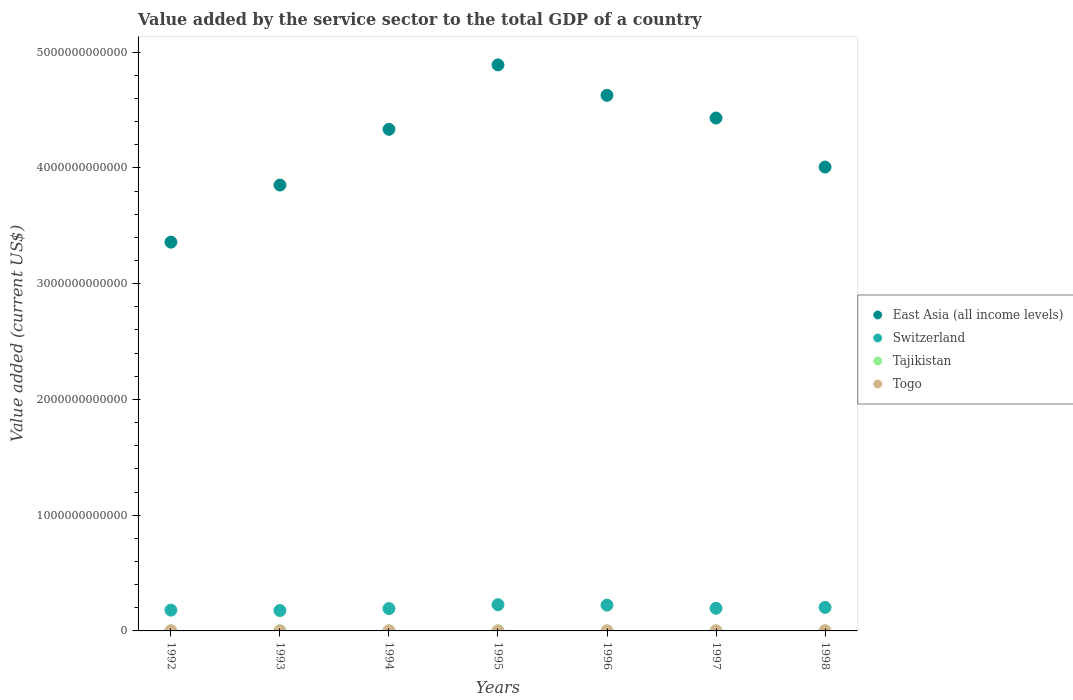What is the value added by the service sector to the total GDP in Switzerland in 1998?
Give a very brief answer. 2.03e+11. Across all years, what is the maximum value added by the service sector to the total GDP in Tajikistan?
Make the answer very short. 5.59e+08. Across all years, what is the minimum value added by the service sector to the total GDP in Togo?
Your answer should be compact. 4.31e+08. In which year was the value added by the service sector to the total GDP in Tajikistan maximum?
Provide a succinct answer. 1998. What is the total value added by the service sector to the total GDP in East Asia (all income levels) in the graph?
Keep it short and to the point. 2.95e+13. What is the difference between the value added by the service sector to the total GDP in Tajikistan in 1992 and that in 1993?
Your answer should be very brief. 9.82e+07. What is the difference between the value added by the service sector to the total GDP in Togo in 1993 and the value added by the service sector to the total GDP in East Asia (all income levels) in 1992?
Ensure brevity in your answer.  -3.36e+12. What is the average value added by the service sector to the total GDP in East Asia (all income levels) per year?
Provide a succinct answer. 4.21e+12. In the year 1994, what is the difference between the value added by the service sector to the total GDP in East Asia (all income levels) and value added by the service sector to the total GDP in Tajikistan?
Your answer should be very brief. 4.33e+12. What is the ratio of the value added by the service sector to the total GDP in East Asia (all income levels) in 1992 to that in 1993?
Make the answer very short. 0.87. What is the difference between the highest and the second highest value added by the service sector to the total GDP in Tajikistan?
Offer a very short reply. 1.32e+07. What is the difference between the highest and the lowest value added by the service sector to the total GDP in East Asia (all income levels)?
Offer a very short reply. 1.53e+12. Does the value added by the service sector to the total GDP in Switzerland monotonically increase over the years?
Give a very brief answer. No. How many dotlines are there?
Ensure brevity in your answer.  4. What is the difference between two consecutive major ticks on the Y-axis?
Provide a short and direct response. 1.00e+12. Does the graph contain any zero values?
Your response must be concise. No. How many legend labels are there?
Your answer should be very brief. 4. What is the title of the graph?
Make the answer very short. Value added by the service sector to the total GDP of a country. Does "Heavily indebted poor countries" appear as one of the legend labels in the graph?
Your response must be concise. No. What is the label or title of the Y-axis?
Ensure brevity in your answer.  Value added (current US$). What is the Value added (current US$) of East Asia (all income levels) in 1992?
Your answer should be compact. 3.36e+12. What is the Value added (current US$) in Switzerland in 1992?
Offer a very short reply. 1.80e+11. What is the Value added (current US$) of Tajikistan in 1992?
Provide a short and direct response. 5.46e+08. What is the Value added (current US$) of Togo in 1992?
Your answer should be very brief. 6.93e+08. What is the Value added (current US$) in East Asia (all income levels) in 1993?
Ensure brevity in your answer.  3.85e+12. What is the Value added (current US$) of Switzerland in 1993?
Ensure brevity in your answer.  1.76e+11. What is the Value added (current US$) of Tajikistan in 1993?
Ensure brevity in your answer.  4.48e+08. What is the Value added (current US$) of Togo in 1993?
Ensure brevity in your answer.  4.34e+08. What is the Value added (current US$) in East Asia (all income levels) in 1994?
Provide a succinct answer. 4.33e+12. What is the Value added (current US$) in Switzerland in 1994?
Offer a terse response. 1.93e+11. What is the Value added (current US$) in Tajikistan in 1994?
Offer a terse response. 3.75e+08. What is the Value added (current US$) in Togo in 1994?
Give a very brief answer. 4.31e+08. What is the Value added (current US$) of East Asia (all income levels) in 1995?
Your answer should be compact. 4.89e+12. What is the Value added (current US$) in Switzerland in 1995?
Offer a terse response. 2.27e+11. What is the Value added (current US$) in Tajikistan in 1995?
Provide a short and direct response. 2.61e+08. What is the Value added (current US$) in Togo in 1995?
Ensure brevity in your answer.  5.24e+08. What is the Value added (current US$) in East Asia (all income levels) in 1996?
Your answer should be compact. 4.63e+12. What is the Value added (current US$) of Switzerland in 1996?
Your answer should be compact. 2.23e+11. What is the Value added (current US$) in Tajikistan in 1996?
Give a very brief answer. 2.84e+08. What is the Value added (current US$) in Togo in 1996?
Ensure brevity in your answer.  5.58e+08. What is the Value added (current US$) in East Asia (all income levels) in 1997?
Offer a terse response. 4.43e+12. What is the Value added (current US$) of Switzerland in 1997?
Provide a short and direct response. 1.96e+11. What is the Value added (current US$) of Tajikistan in 1997?
Give a very brief answer. 2.99e+08. What is the Value added (current US$) in Togo in 1997?
Your response must be concise. 5.65e+08. What is the Value added (current US$) of East Asia (all income levels) in 1998?
Ensure brevity in your answer.  4.01e+12. What is the Value added (current US$) in Switzerland in 1998?
Ensure brevity in your answer.  2.03e+11. What is the Value added (current US$) of Tajikistan in 1998?
Keep it short and to the point. 5.59e+08. What is the Value added (current US$) of Togo in 1998?
Your answer should be very brief. 7.65e+08. Across all years, what is the maximum Value added (current US$) of East Asia (all income levels)?
Provide a short and direct response. 4.89e+12. Across all years, what is the maximum Value added (current US$) in Switzerland?
Your answer should be compact. 2.27e+11. Across all years, what is the maximum Value added (current US$) of Tajikistan?
Your answer should be compact. 5.59e+08. Across all years, what is the maximum Value added (current US$) in Togo?
Offer a terse response. 7.65e+08. Across all years, what is the minimum Value added (current US$) of East Asia (all income levels)?
Provide a short and direct response. 3.36e+12. Across all years, what is the minimum Value added (current US$) of Switzerland?
Give a very brief answer. 1.76e+11. Across all years, what is the minimum Value added (current US$) of Tajikistan?
Your response must be concise. 2.61e+08. Across all years, what is the minimum Value added (current US$) in Togo?
Provide a succinct answer. 4.31e+08. What is the total Value added (current US$) in East Asia (all income levels) in the graph?
Provide a short and direct response. 2.95e+13. What is the total Value added (current US$) in Switzerland in the graph?
Keep it short and to the point. 1.40e+12. What is the total Value added (current US$) in Tajikistan in the graph?
Ensure brevity in your answer.  2.77e+09. What is the total Value added (current US$) in Togo in the graph?
Keep it short and to the point. 3.97e+09. What is the difference between the Value added (current US$) in East Asia (all income levels) in 1992 and that in 1993?
Provide a succinct answer. -4.93e+11. What is the difference between the Value added (current US$) in Switzerland in 1992 and that in 1993?
Your answer should be very brief. 3.49e+09. What is the difference between the Value added (current US$) in Tajikistan in 1992 and that in 1993?
Your answer should be very brief. 9.82e+07. What is the difference between the Value added (current US$) in Togo in 1992 and that in 1993?
Your response must be concise. 2.60e+08. What is the difference between the Value added (current US$) of East Asia (all income levels) in 1992 and that in 1994?
Your answer should be very brief. -9.75e+11. What is the difference between the Value added (current US$) of Switzerland in 1992 and that in 1994?
Your answer should be very brief. -1.33e+1. What is the difference between the Value added (current US$) in Tajikistan in 1992 and that in 1994?
Give a very brief answer. 1.71e+08. What is the difference between the Value added (current US$) of Togo in 1992 and that in 1994?
Provide a short and direct response. 2.63e+08. What is the difference between the Value added (current US$) in East Asia (all income levels) in 1992 and that in 1995?
Provide a succinct answer. -1.53e+12. What is the difference between the Value added (current US$) of Switzerland in 1992 and that in 1995?
Your answer should be very brief. -4.68e+1. What is the difference between the Value added (current US$) in Tajikistan in 1992 and that in 1995?
Your response must be concise. 2.85e+08. What is the difference between the Value added (current US$) of Togo in 1992 and that in 1995?
Your answer should be very brief. 1.69e+08. What is the difference between the Value added (current US$) in East Asia (all income levels) in 1992 and that in 1996?
Your response must be concise. -1.27e+12. What is the difference between the Value added (current US$) of Switzerland in 1992 and that in 1996?
Keep it short and to the point. -4.32e+1. What is the difference between the Value added (current US$) of Tajikistan in 1992 and that in 1996?
Give a very brief answer. 2.62e+08. What is the difference between the Value added (current US$) of Togo in 1992 and that in 1996?
Provide a succinct answer. 1.35e+08. What is the difference between the Value added (current US$) of East Asia (all income levels) in 1992 and that in 1997?
Provide a short and direct response. -1.07e+12. What is the difference between the Value added (current US$) in Switzerland in 1992 and that in 1997?
Make the answer very short. -1.58e+1. What is the difference between the Value added (current US$) of Tajikistan in 1992 and that in 1997?
Give a very brief answer. 2.47e+08. What is the difference between the Value added (current US$) of Togo in 1992 and that in 1997?
Make the answer very short. 1.29e+08. What is the difference between the Value added (current US$) in East Asia (all income levels) in 1992 and that in 1998?
Ensure brevity in your answer.  -6.49e+11. What is the difference between the Value added (current US$) in Switzerland in 1992 and that in 1998?
Ensure brevity in your answer.  -2.35e+1. What is the difference between the Value added (current US$) in Tajikistan in 1992 and that in 1998?
Provide a succinct answer. -1.32e+07. What is the difference between the Value added (current US$) in Togo in 1992 and that in 1998?
Provide a short and direct response. -7.12e+07. What is the difference between the Value added (current US$) of East Asia (all income levels) in 1993 and that in 1994?
Offer a very short reply. -4.81e+11. What is the difference between the Value added (current US$) of Switzerland in 1993 and that in 1994?
Your response must be concise. -1.68e+1. What is the difference between the Value added (current US$) of Tajikistan in 1993 and that in 1994?
Offer a terse response. 7.25e+07. What is the difference between the Value added (current US$) in Togo in 1993 and that in 1994?
Your answer should be compact. 3.06e+06. What is the difference between the Value added (current US$) of East Asia (all income levels) in 1993 and that in 1995?
Your answer should be compact. -1.04e+12. What is the difference between the Value added (current US$) in Switzerland in 1993 and that in 1995?
Keep it short and to the point. -5.03e+1. What is the difference between the Value added (current US$) in Tajikistan in 1993 and that in 1995?
Your response must be concise. 1.86e+08. What is the difference between the Value added (current US$) in Togo in 1993 and that in 1995?
Your answer should be compact. -9.06e+07. What is the difference between the Value added (current US$) in East Asia (all income levels) in 1993 and that in 1996?
Your response must be concise. -7.75e+11. What is the difference between the Value added (current US$) in Switzerland in 1993 and that in 1996?
Make the answer very short. -4.67e+1. What is the difference between the Value added (current US$) in Tajikistan in 1993 and that in 1996?
Keep it short and to the point. 1.64e+08. What is the difference between the Value added (current US$) of Togo in 1993 and that in 1996?
Your answer should be very brief. -1.24e+08. What is the difference between the Value added (current US$) of East Asia (all income levels) in 1993 and that in 1997?
Offer a terse response. -5.79e+11. What is the difference between the Value added (current US$) of Switzerland in 1993 and that in 1997?
Provide a short and direct response. -1.93e+1. What is the difference between the Value added (current US$) in Tajikistan in 1993 and that in 1997?
Ensure brevity in your answer.  1.48e+08. What is the difference between the Value added (current US$) in Togo in 1993 and that in 1997?
Give a very brief answer. -1.31e+08. What is the difference between the Value added (current US$) of East Asia (all income levels) in 1993 and that in 1998?
Offer a terse response. -1.55e+11. What is the difference between the Value added (current US$) in Switzerland in 1993 and that in 1998?
Provide a succinct answer. -2.70e+1. What is the difference between the Value added (current US$) in Tajikistan in 1993 and that in 1998?
Your response must be concise. -1.11e+08. What is the difference between the Value added (current US$) in Togo in 1993 and that in 1998?
Your response must be concise. -3.31e+08. What is the difference between the Value added (current US$) of East Asia (all income levels) in 1994 and that in 1995?
Provide a succinct answer. -5.57e+11. What is the difference between the Value added (current US$) in Switzerland in 1994 and that in 1995?
Your answer should be compact. -3.34e+1. What is the difference between the Value added (current US$) in Tajikistan in 1994 and that in 1995?
Provide a short and direct response. 1.14e+08. What is the difference between the Value added (current US$) of Togo in 1994 and that in 1995?
Your response must be concise. -9.36e+07. What is the difference between the Value added (current US$) in East Asia (all income levels) in 1994 and that in 1996?
Your answer should be compact. -2.94e+11. What is the difference between the Value added (current US$) of Switzerland in 1994 and that in 1996?
Provide a short and direct response. -2.98e+1. What is the difference between the Value added (current US$) of Tajikistan in 1994 and that in 1996?
Your response must be concise. 9.10e+07. What is the difference between the Value added (current US$) of Togo in 1994 and that in 1996?
Your response must be concise. -1.27e+08. What is the difference between the Value added (current US$) in East Asia (all income levels) in 1994 and that in 1997?
Provide a succinct answer. -9.73e+1. What is the difference between the Value added (current US$) in Switzerland in 1994 and that in 1997?
Make the answer very short. -2.48e+09. What is the difference between the Value added (current US$) in Tajikistan in 1994 and that in 1997?
Your answer should be compact. 7.58e+07. What is the difference between the Value added (current US$) in Togo in 1994 and that in 1997?
Ensure brevity in your answer.  -1.34e+08. What is the difference between the Value added (current US$) of East Asia (all income levels) in 1994 and that in 1998?
Make the answer very short. 3.26e+11. What is the difference between the Value added (current US$) in Switzerland in 1994 and that in 1998?
Offer a terse response. -1.02e+1. What is the difference between the Value added (current US$) of Tajikistan in 1994 and that in 1998?
Your response must be concise. -1.84e+08. What is the difference between the Value added (current US$) in Togo in 1994 and that in 1998?
Ensure brevity in your answer.  -3.34e+08. What is the difference between the Value added (current US$) in East Asia (all income levels) in 1995 and that in 1996?
Give a very brief answer. 2.63e+11. What is the difference between the Value added (current US$) of Switzerland in 1995 and that in 1996?
Ensure brevity in your answer.  3.59e+09. What is the difference between the Value added (current US$) of Tajikistan in 1995 and that in 1996?
Your answer should be compact. -2.28e+07. What is the difference between the Value added (current US$) of Togo in 1995 and that in 1996?
Keep it short and to the point. -3.39e+07. What is the difference between the Value added (current US$) in East Asia (all income levels) in 1995 and that in 1997?
Keep it short and to the point. 4.59e+11. What is the difference between the Value added (current US$) of Switzerland in 1995 and that in 1997?
Your response must be concise. 3.09e+1. What is the difference between the Value added (current US$) in Tajikistan in 1995 and that in 1997?
Ensure brevity in your answer.  -3.81e+07. What is the difference between the Value added (current US$) of Togo in 1995 and that in 1997?
Make the answer very short. -4.04e+07. What is the difference between the Value added (current US$) of East Asia (all income levels) in 1995 and that in 1998?
Make the answer very short. 8.83e+11. What is the difference between the Value added (current US$) of Switzerland in 1995 and that in 1998?
Provide a short and direct response. 2.32e+1. What is the difference between the Value added (current US$) in Tajikistan in 1995 and that in 1998?
Provide a short and direct response. -2.98e+08. What is the difference between the Value added (current US$) in Togo in 1995 and that in 1998?
Give a very brief answer. -2.40e+08. What is the difference between the Value added (current US$) of East Asia (all income levels) in 1996 and that in 1997?
Your answer should be very brief. 1.96e+11. What is the difference between the Value added (current US$) of Switzerland in 1996 and that in 1997?
Provide a short and direct response. 2.73e+1. What is the difference between the Value added (current US$) in Tajikistan in 1996 and that in 1997?
Provide a short and direct response. -1.53e+07. What is the difference between the Value added (current US$) in Togo in 1996 and that in 1997?
Offer a terse response. -6.50e+06. What is the difference between the Value added (current US$) in East Asia (all income levels) in 1996 and that in 1998?
Your response must be concise. 6.20e+11. What is the difference between the Value added (current US$) of Switzerland in 1996 and that in 1998?
Offer a terse response. 1.96e+1. What is the difference between the Value added (current US$) of Tajikistan in 1996 and that in 1998?
Your response must be concise. -2.75e+08. What is the difference between the Value added (current US$) in Togo in 1996 and that in 1998?
Ensure brevity in your answer.  -2.06e+08. What is the difference between the Value added (current US$) of East Asia (all income levels) in 1997 and that in 1998?
Your response must be concise. 4.23e+11. What is the difference between the Value added (current US$) of Switzerland in 1997 and that in 1998?
Offer a very short reply. -7.70e+09. What is the difference between the Value added (current US$) of Tajikistan in 1997 and that in 1998?
Provide a short and direct response. -2.60e+08. What is the difference between the Value added (current US$) of Togo in 1997 and that in 1998?
Your response must be concise. -2.00e+08. What is the difference between the Value added (current US$) in East Asia (all income levels) in 1992 and the Value added (current US$) in Switzerland in 1993?
Ensure brevity in your answer.  3.18e+12. What is the difference between the Value added (current US$) in East Asia (all income levels) in 1992 and the Value added (current US$) in Tajikistan in 1993?
Give a very brief answer. 3.36e+12. What is the difference between the Value added (current US$) of East Asia (all income levels) in 1992 and the Value added (current US$) of Togo in 1993?
Make the answer very short. 3.36e+12. What is the difference between the Value added (current US$) of Switzerland in 1992 and the Value added (current US$) of Tajikistan in 1993?
Make the answer very short. 1.79e+11. What is the difference between the Value added (current US$) in Switzerland in 1992 and the Value added (current US$) in Togo in 1993?
Your answer should be compact. 1.79e+11. What is the difference between the Value added (current US$) of Tajikistan in 1992 and the Value added (current US$) of Togo in 1993?
Offer a very short reply. 1.12e+08. What is the difference between the Value added (current US$) in East Asia (all income levels) in 1992 and the Value added (current US$) in Switzerland in 1994?
Give a very brief answer. 3.17e+12. What is the difference between the Value added (current US$) in East Asia (all income levels) in 1992 and the Value added (current US$) in Tajikistan in 1994?
Give a very brief answer. 3.36e+12. What is the difference between the Value added (current US$) in East Asia (all income levels) in 1992 and the Value added (current US$) in Togo in 1994?
Your answer should be compact. 3.36e+12. What is the difference between the Value added (current US$) of Switzerland in 1992 and the Value added (current US$) of Tajikistan in 1994?
Your answer should be very brief. 1.79e+11. What is the difference between the Value added (current US$) in Switzerland in 1992 and the Value added (current US$) in Togo in 1994?
Make the answer very short. 1.79e+11. What is the difference between the Value added (current US$) of Tajikistan in 1992 and the Value added (current US$) of Togo in 1994?
Provide a succinct answer. 1.15e+08. What is the difference between the Value added (current US$) of East Asia (all income levels) in 1992 and the Value added (current US$) of Switzerland in 1995?
Offer a very short reply. 3.13e+12. What is the difference between the Value added (current US$) in East Asia (all income levels) in 1992 and the Value added (current US$) in Tajikistan in 1995?
Ensure brevity in your answer.  3.36e+12. What is the difference between the Value added (current US$) of East Asia (all income levels) in 1992 and the Value added (current US$) of Togo in 1995?
Your answer should be compact. 3.36e+12. What is the difference between the Value added (current US$) of Switzerland in 1992 and the Value added (current US$) of Tajikistan in 1995?
Ensure brevity in your answer.  1.79e+11. What is the difference between the Value added (current US$) in Switzerland in 1992 and the Value added (current US$) in Togo in 1995?
Offer a very short reply. 1.79e+11. What is the difference between the Value added (current US$) in Tajikistan in 1992 and the Value added (current US$) in Togo in 1995?
Make the answer very short. 2.14e+07. What is the difference between the Value added (current US$) in East Asia (all income levels) in 1992 and the Value added (current US$) in Switzerland in 1996?
Offer a terse response. 3.14e+12. What is the difference between the Value added (current US$) of East Asia (all income levels) in 1992 and the Value added (current US$) of Tajikistan in 1996?
Ensure brevity in your answer.  3.36e+12. What is the difference between the Value added (current US$) of East Asia (all income levels) in 1992 and the Value added (current US$) of Togo in 1996?
Your answer should be compact. 3.36e+12. What is the difference between the Value added (current US$) in Switzerland in 1992 and the Value added (current US$) in Tajikistan in 1996?
Offer a very short reply. 1.79e+11. What is the difference between the Value added (current US$) in Switzerland in 1992 and the Value added (current US$) in Togo in 1996?
Provide a succinct answer. 1.79e+11. What is the difference between the Value added (current US$) in Tajikistan in 1992 and the Value added (current US$) in Togo in 1996?
Provide a succinct answer. -1.25e+07. What is the difference between the Value added (current US$) in East Asia (all income levels) in 1992 and the Value added (current US$) in Switzerland in 1997?
Offer a terse response. 3.16e+12. What is the difference between the Value added (current US$) of East Asia (all income levels) in 1992 and the Value added (current US$) of Tajikistan in 1997?
Provide a short and direct response. 3.36e+12. What is the difference between the Value added (current US$) of East Asia (all income levels) in 1992 and the Value added (current US$) of Togo in 1997?
Make the answer very short. 3.36e+12. What is the difference between the Value added (current US$) in Switzerland in 1992 and the Value added (current US$) in Tajikistan in 1997?
Provide a short and direct response. 1.79e+11. What is the difference between the Value added (current US$) in Switzerland in 1992 and the Value added (current US$) in Togo in 1997?
Your response must be concise. 1.79e+11. What is the difference between the Value added (current US$) in Tajikistan in 1992 and the Value added (current US$) in Togo in 1997?
Your response must be concise. -1.89e+07. What is the difference between the Value added (current US$) in East Asia (all income levels) in 1992 and the Value added (current US$) in Switzerland in 1998?
Offer a terse response. 3.16e+12. What is the difference between the Value added (current US$) of East Asia (all income levels) in 1992 and the Value added (current US$) of Tajikistan in 1998?
Provide a succinct answer. 3.36e+12. What is the difference between the Value added (current US$) of East Asia (all income levels) in 1992 and the Value added (current US$) of Togo in 1998?
Your answer should be compact. 3.36e+12. What is the difference between the Value added (current US$) of Switzerland in 1992 and the Value added (current US$) of Tajikistan in 1998?
Make the answer very short. 1.79e+11. What is the difference between the Value added (current US$) in Switzerland in 1992 and the Value added (current US$) in Togo in 1998?
Offer a terse response. 1.79e+11. What is the difference between the Value added (current US$) of Tajikistan in 1992 and the Value added (current US$) of Togo in 1998?
Ensure brevity in your answer.  -2.19e+08. What is the difference between the Value added (current US$) of East Asia (all income levels) in 1993 and the Value added (current US$) of Switzerland in 1994?
Ensure brevity in your answer.  3.66e+12. What is the difference between the Value added (current US$) of East Asia (all income levels) in 1993 and the Value added (current US$) of Tajikistan in 1994?
Provide a succinct answer. 3.85e+12. What is the difference between the Value added (current US$) in East Asia (all income levels) in 1993 and the Value added (current US$) in Togo in 1994?
Provide a short and direct response. 3.85e+12. What is the difference between the Value added (current US$) of Switzerland in 1993 and the Value added (current US$) of Tajikistan in 1994?
Ensure brevity in your answer.  1.76e+11. What is the difference between the Value added (current US$) in Switzerland in 1993 and the Value added (current US$) in Togo in 1994?
Your answer should be compact. 1.76e+11. What is the difference between the Value added (current US$) of Tajikistan in 1993 and the Value added (current US$) of Togo in 1994?
Make the answer very short. 1.68e+07. What is the difference between the Value added (current US$) in East Asia (all income levels) in 1993 and the Value added (current US$) in Switzerland in 1995?
Offer a very short reply. 3.63e+12. What is the difference between the Value added (current US$) of East Asia (all income levels) in 1993 and the Value added (current US$) of Tajikistan in 1995?
Ensure brevity in your answer.  3.85e+12. What is the difference between the Value added (current US$) in East Asia (all income levels) in 1993 and the Value added (current US$) in Togo in 1995?
Offer a very short reply. 3.85e+12. What is the difference between the Value added (current US$) in Switzerland in 1993 and the Value added (current US$) in Tajikistan in 1995?
Make the answer very short. 1.76e+11. What is the difference between the Value added (current US$) in Switzerland in 1993 and the Value added (current US$) in Togo in 1995?
Your response must be concise. 1.76e+11. What is the difference between the Value added (current US$) of Tajikistan in 1993 and the Value added (current US$) of Togo in 1995?
Give a very brief answer. -7.68e+07. What is the difference between the Value added (current US$) of East Asia (all income levels) in 1993 and the Value added (current US$) of Switzerland in 1996?
Give a very brief answer. 3.63e+12. What is the difference between the Value added (current US$) in East Asia (all income levels) in 1993 and the Value added (current US$) in Tajikistan in 1996?
Give a very brief answer. 3.85e+12. What is the difference between the Value added (current US$) of East Asia (all income levels) in 1993 and the Value added (current US$) of Togo in 1996?
Provide a succinct answer. 3.85e+12. What is the difference between the Value added (current US$) of Switzerland in 1993 and the Value added (current US$) of Tajikistan in 1996?
Offer a very short reply. 1.76e+11. What is the difference between the Value added (current US$) of Switzerland in 1993 and the Value added (current US$) of Togo in 1996?
Ensure brevity in your answer.  1.76e+11. What is the difference between the Value added (current US$) of Tajikistan in 1993 and the Value added (current US$) of Togo in 1996?
Offer a very short reply. -1.11e+08. What is the difference between the Value added (current US$) in East Asia (all income levels) in 1993 and the Value added (current US$) in Switzerland in 1997?
Offer a terse response. 3.66e+12. What is the difference between the Value added (current US$) of East Asia (all income levels) in 1993 and the Value added (current US$) of Tajikistan in 1997?
Your answer should be compact. 3.85e+12. What is the difference between the Value added (current US$) in East Asia (all income levels) in 1993 and the Value added (current US$) in Togo in 1997?
Your answer should be compact. 3.85e+12. What is the difference between the Value added (current US$) of Switzerland in 1993 and the Value added (current US$) of Tajikistan in 1997?
Your answer should be very brief. 1.76e+11. What is the difference between the Value added (current US$) in Switzerland in 1993 and the Value added (current US$) in Togo in 1997?
Ensure brevity in your answer.  1.76e+11. What is the difference between the Value added (current US$) in Tajikistan in 1993 and the Value added (current US$) in Togo in 1997?
Provide a succinct answer. -1.17e+08. What is the difference between the Value added (current US$) in East Asia (all income levels) in 1993 and the Value added (current US$) in Switzerland in 1998?
Ensure brevity in your answer.  3.65e+12. What is the difference between the Value added (current US$) in East Asia (all income levels) in 1993 and the Value added (current US$) in Tajikistan in 1998?
Offer a very short reply. 3.85e+12. What is the difference between the Value added (current US$) in East Asia (all income levels) in 1993 and the Value added (current US$) in Togo in 1998?
Your response must be concise. 3.85e+12. What is the difference between the Value added (current US$) of Switzerland in 1993 and the Value added (current US$) of Tajikistan in 1998?
Ensure brevity in your answer.  1.76e+11. What is the difference between the Value added (current US$) in Switzerland in 1993 and the Value added (current US$) in Togo in 1998?
Ensure brevity in your answer.  1.75e+11. What is the difference between the Value added (current US$) in Tajikistan in 1993 and the Value added (current US$) in Togo in 1998?
Your response must be concise. -3.17e+08. What is the difference between the Value added (current US$) of East Asia (all income levels) in 1994 and the Value added (current US$) of Switzerland in 1995?
Your answer should be very brief. 4.11e+12. What is the difference between the Value added (current US$) of East Asia (all income levels) in 1994 and the Value added (current US$) of Tajikistan in 1995?
Provide a succinct answer. 4.33e+12. What is the difference between the Value added (current US$) in East Asia (all income levels) in 1994 and the Value added (current US$) in Togo in 1995?
Your response must be concise. 4.33e+12. What is the difference between the Value added (current US$) in Switzerland in 1994 and the Value added (current US$) in Tajikistan in 1995?
Provide a succinct answer. 1.93e+11. What is the difference between the Value added (current US$) of Switzerland in 1994 and the Value added (current US$) of Togo in 1995?
Ensure brevity in your answer.  1.93e+11. What is the difference between the Value added (current US$) of Tajikistan in 1994 and the Value added (current US$) of Togo in 1995?
Your answer should be very brief. -1.49e+08. What is the difference between the Value added (current US$) in East Asia (all income levels) in 1994 and the Value added (current US$) in Switzerland in 1996?
Make the answer very short. 4.11e+12. What is the difference between the Value added (current US$) of East Asia (all income levels) in 1994 and the Value added (current US$) of Tajikistan in 1996?
Offer a terse response. 4.33e+12. What is the difference between the Value added (current US$) of East Asia (all income levels) in 1994 and the Value added (current US$) of Togo in 1996?
Offer a terse response. 4.33e+12. What is the difference between the Value added (current US$) in Switzerland in 1994 and the Value added (current US$) in Tajikistan in 1996?
Make the answer very short. 1.93e+11. What is the difference between the Value added (current US$) in Switzerland in 1994 and the Value added (current US$) in Togo in 1996?
Your answer should be very brief. 1.93e+11. What is the difference between the Value added (current US$) in Tajikistan in 1994 and the Value added (current US$) in Togo in 1996?
Your answer should be very brief. -1.83e+08. What is the difference between the Value added (current US$) of East Asia (all income levels) in 1994 and the Value added (current US$) of Switzerland in 1997?
Offer a terse response. 4.14e+12. What is the difference between the Value added (current US$) in East Asia (all income levels) in 1994 and the Value added (current US$) in Tajikistan in 1997?
Keep it short and to the point. 4.33e+12. What is the difference between the Value added (current US$) in East Asia (all income levels) in 1994 and the Value added (current US$) in Togo in 1997?
Your answer should be compact. 4.33e+12. What is the difference between the Value added (current US$) of Switzerland in 1994 and the Value added (current US$) of Tajikistan in 1997?
Your answer should be very brief. 1.93e+11. What is the difference between the Value added (current US$) in Switzerland in 1994 and the Value added (current US$) in Togo in 1997?
Ensure brevity in your answer.  1.93e+11. What is the difference between the Value added (current US$) in Tajikistan in 1994 and the Value added (current US$) in Togo in 1997?
Your answer should be compact. -1.90e+08. What is the difference between the Value added (current US$) in East Asia (all income levels) in 1994 and the Value added (current US$) in Switzerland in 1998?
Your response must be concise. 4.13e+12. What is the difference between the Value added (current US$) in East Asia (all income levels) in 1994 and the Value added (current US$) in Tajikistan in 1998?
Your answer should be very brief. 4.33e+12. What is the difference between the Value added (current US$) of East Asia (all income levels) in 1994 and the Value added (current US$) of Togo in 1998?
Keep it short and to the point. 4.33e+12. What is the difference between the Value added (current US$) in Switzerland in 1994 and the Value added (current US$) in Tajikistan in 1998?
Provide a short and direct response. 1.93e+11. What is the difference between the Value added (current US$) of Switzerland in 1994 and the Value added (current US$) of Togo in 1998?
Provide a succinct answer. 1.92e+11. What is the difference between the Value added (current US$) in Tajikistan in 1994 and the Value added (current US$) in Togo in 1998?
Make the answer very short. -3.90e+08. What is the difference between the Value added (current US$) in East Asia (all income levels) in 1995 and the Value added (current US$) in Switzerland in 1996?
Provide a succinct answer. 4.67e+12. What is the difference between the Value added (current US$) in East Asia (all income levels) in 1995 and the Value added (current US$) in Tajikistan in 1996?
Offer a very short reply. 4.89e+12. What is the difference between the Value added (current US$) in East Asia (all income levels) in 1995 and the Value added (current US$) in Togo in 1996?
Provide a succinct answer. 4.89e+12. What is the difference between the Value added (current US$) in Switzerland in 1995 and the Value added (current US$) in Tajikistan in 1996?
Your answer should be compact. 2.26e+11. What is the difference between the Value added (current US$) of Switzerland in 1995 and the Value added (current US$) of Togo in 1996?
Offer a very short reply. 2.26e+11. What is the difference between the Value added (current US$) of Tajikistan in 1995 and the Value added (current US$) of Togo in 1996?
Provide a succinct answer. -2.97e+08. What is the difference between the Value added (current US$) in East Asia (all income levels) in 1995 and the Value added (current US$) in Switzerland in 1997?
Offer a terse response. 4.69e+12. What is the difference between the Value added (current US$) of East Asia (all income levels) in 1995 and the Value added (current US$) of Tajikistan in 1997?
Provide a succinct answer. 4.89e+12. What is the difference between the Value added (current US$) of East Asia (all income levels) in 1995 and the Value added (current US$) of Togo in 1997?
Keep it short and to the point. 4.89e+12. What is the difference between the Value added (current US$) of Switzerland in 1995 and the Value added (current US$) of Tajikistan in 1997?
Keep it short and to the point. 2.26e+11. What is the difference between the Value added (current US$) of Switzerland in 1995 and the Value added (current US$) of Togo in 1997?
Offer a terse response. 2.26e+11. What is the difference between the Value added (current US$) in Tajikistan in 1995 and the Value added (current US$) in Togo in 1997?
Provide a succinct answer. -3.04e+08. What is the difference between the Value added (current US$) in East Asia (all income levels) in 1995 and the Value added (current US$) in Switzerland in 1998?
Offer a terse response. 4.69e+12. What is the difference between the Value added (current US$) of East Asia (all income levels) in 1995 and the Value added (current US$) of Tajikistan in 1998?
Keep it short and to the point. 4.89e+12. What is the difference between the Value added (current US$) of East Asia (all income levels) in 1995 and the Value added (current US$) of Togo in 1998?
Your answer should be compact. 4.89e+12. What is the difference between the Value added (current US$) of Switzerland in 1995 and the Value added (current US$) of Tajikistan in 1998?
Offer a very short reply. 2.26e+11. What is the difference between the Value added (current US$) of Switzerland in 1995 and the Value added (current US$) of Togo in 1998?
Your response must be concise. 2.26e+11. What is the difference between the Value added (current US$) in Tajikistan in 1995 and the Value added (current US$) in Togo in 1998?
Keep it short and to the point. -5.03e+08. What is the difference between the Value added (current US$) in East Asia (all income levels) in 1996 and the Value added (current US$) in Switzerland in 1997?
Make the answer very short. 4.43e+12. What is the difference between the Value added (current US$) in East Asia (all income levels) in 1996 and the Value added (current US$) in Tajikistan in 1997?
Make the answer very short. 4.63e+12. What is the difference between the Value added (current US$) in East Asia (all income levels) in 1996 and the Value added (current US$) in Togo in 1997?
Your response must be concise. 4.63e+12. What is the difference between the Value added (current US$) of Switzerland in 1996 and the Value added (current US$) of Tajikistan in 1997?
Offer a very short reply. 2.23e+11. What is the difference between the Value added (current US$) in Switzerland in 1996 and the Value added (current US$) in Togo in 1997?
Your answer should be compact. 2.22e+11. What is the difference between the Value added (current US$) in Tajikistan in 1996 and the Value added (current US$) in Togo in 1997?
Your response must be concise. -2.81e+08. What is the difference between the Value added (current US$) in East Asia (all income levels) in 1996 and the Value added (current US$) in Switzerland in 1998?
Provide a succinct answer. 4.42e+12. What is the difference between the Value added (current US$) of East Asia (all income levels) in 1996 and the Value added (current US$) of Tajikistan in 1998?
Provide a succinct answer. 4.63e+12. What is the difference between the Value added (current US$) in East Asia (all income levels) in 1996 and the Value added (current US$) in Togo in 1998?
Give a very brief answer. 4.63e+12. What is the difference between the Value added (current US$) of Switzerland in 1996 and the Value added (current US$) of Tajikistan in 1998?
Provide a short and direct response. 2.22e+11. What is the difference between the Value added (current US$) in Switzerland in 1996 and the Value added (current US$) in Togo in 1998?
Your answer should be compact. 2.22e+11. What is the difference between the Value added (current US$) of Tajikistan in 1996 and the Value added (current US$) of Togo in 1998?
Your answer should be very brief. -4.81e+08. What is the difference between the Value added (current US$) in East Asia (all income levels) in 1997 and the Value added (current US$) in Switzerland in 1998?
Keep it short and to the point. 4.23e+12. What is the difference between the Value added (current US$) of East Asia (all income levels) in 1997 and the Value added (current US$) of Tajikistan in 1998?
Offer a very short reply. 4.43e+12. What is the difference between the Value added (current US$) in East Asia (all income levels) in 1997 and the Value added (current US$) in Togo in 1998?
Offer a very short reply. 4.43e+12. What is the difference between the Value added (current US$) in Switzerland in 1997 and the Value added (current US$) in Tajikistan in 1998?
Your answer should be compact. 1.95e+11. What is the difference between the Value added (current US$) of Switzerland in 1997 and the Value added (current US$) of Togo in 1998?
Give a very brief answer. 1.95e+11. What is the difference between the Value added (current US$) of Tajikistan in 1997 and the Value added (current US$) of Togo in 1998?
Make the answer very short. -4.65e+08. What is the average Value added (current US$) of East Asia (all income levels) per year?
Make the answer very short. 4.21e+12. What is the average Value added (current US$) of Switzerland per year?
Your answer should be compact. 2.00e+11. What is the average Value added (current US$) of Tajikistan per year?
Your response must be concise. 3.96e+08. What is the average Value added (current US$) of Togo per year?
Give a very brief answer. 5.67e+08. In the year 1992, what is the difference between the Value added (current US$) in East Asia (all income levels) and Value added (current US$) in Switzerland?
Your response must be concise. 3.18e+12. In the year 1992, what is the difference between the Value added (current US$) of East Asia (all income levels) and Value added (current US$) of Tajikistan?
Give a very brief answer. 3.36e+12. In the year 1992, what is the difference between the Value added (current US$) in East Asia (all income levels) and Value added (current US$) in Togo?
Provide a succinct answer. 3.36e+12. In the year 1992, what is the difference between the Value added (current US$) of Switzerland and Value added (current US$) of Tajikistan?
Your answer should be compact. 1.79e+11. In the year 1992, what is the difference between the Value added (current US$) of Switzerland and Value added (current US$) of Togo?
Make the answer very short. 1.79e+11. In the year 1992, what is the difference between the Value added (current US$) of Tajikistan and Value added (current US$) of Togo?
Your answer should be very brief. -1.48e+08. In the year 1993, what is the difference between the Value added (current US$) of East Asia (all income levels) and Value added (current US$) of Switzerland?
Give a very brief answer. 3.68e+12. In the year 1993, what is the difference between the Value added (current US$) of East Asia (all income levels) and Value added (current US$) of Tajikistan?
Make the answer very short. 3.85e+12. In the year 1993, what is the difference between the Value added (current US$) in East Asia (all income levels) and Value added (current US$) in Togo?
Provide a succinct answer. 3.85e+12. In the year 1993, what is the difference between the Value added (current US$) of Switzerland and Value added (current US$) of Tajikistan?
Provide a short and direct response. 1.76e+11. In the year 1993, what is the difference between the Value added (current US$) of Switzerland and Value added (current US$) of Togo?
Your answer should be compact. 1.76e+11. In the year 1993, what is the difference between the Value added (current US$) of Tajikistan and Value added (current US$) of Togo?
Ensure brevity in your answer.  1.38e+07. In the year 1994, what is the difference between the Value added (current US$) in East Asia (all income levels) and Value added (current US$) in Switzerland?
Make the answer very short. 4.14e+12. In the year 1994, what is the difference between the Value added (current US$) of East Asia (all income levels) and Value added (current US$) of Tajikistan?
Your answer should be very brief. 4.33e+12. In the year 1994, what is the difference between the Value added (current US$) in East Asia (all income levels) and Value added (current US$) in Togo?
Make the answer very short. 4.33e+12. In the year 1994, what is the difference between the Value added (current US$) of Switzerland and Value added (current US$) of Tajikistan?
Offer a very short reply. 1.93e+11. In the year 1994, what is the difference between the Value added (current US$) in Switzerland and Value added (current US$) in Togo?
Offer a terse response. 1.93e+11. In the year 1994, what is the difference between the Value added (current US$) in Tajikistan and Value added (current US$) in Togo?
Your response must be concise. -5.57e+07. In the year 1995, what is the difference between the Value added (current US$) of East Asia (all income levels) and Value added (current US$) of Switzerland?
Ensure brevity in your answer.  4.66e+12. In the year 1995, what is the difference between the Value added (current US$) in East Asia (all income levels) and Value added (current US$) in Tajikistan?
Offer a very short reply. 4.89e+12. In the year 1995, what is the difference between the Value added (current US$) of East Asia (all income levels) and Value added (current US$) of Togo?
Offer a very short reply. 4.89e+12. In the year 1995, what is the difference between the Value added (current US$) in Switzerland and Value added (current US$) in Tajikistan?
Your answer should be compact. 2.26e+11. In the year 1995, what is the difference between the Value added (current US$) of Switzerland and Value added (current US$) of Togo?
Your answer should be very brief. 2.26e+11. In the year 1995, what is the difference between the Value added (current US$) of Tajikistan and Value added (current US$) of Togo?
Make the answer very short. -2.63e+08. In the year 1996, what is the difference between the Value added (current US$) in East Asia (all income levels) and Value added (current US$) in Switzerland?
Your response must be concise. 4.40e+12. In the year 1996, what is the difference between the Value added (current US$) in East Asia (all income levels) and Value added (current US$) in Tajikistan?
Ensure brevity in your answer.  4.63e+12. In the year 1996, what is the difference between the Value added (current US$) in East Asia (all income levels) and Value added (current US$) in Togo?
Give a very brief answer. 4.63e+12. In the year 1996, what is the difference between the Value added (current US$) of Switzerland and Value added (current US$) of Tajikistan?
Make the answer very short. 2.23e+11. In the year 1996, what is the difference between the Value added (current US$) of Switzerland and Value added (current US$) of Togo?
Keep it short and to the point. 2.22e+11. In the year 1996, what is the difference between the Value added (current US$) of Tajikistan and Value added (current US$) of Togo?
Provide a short and direct response. -2.74e+08. In the year 1997, what is the difference between the Value added (current US$) of East Asia (all income levels) and Value added (current US$) of Switzerland?
Your response must be concise. 4.24e+12. In the year 1997, what is the difference between the Value added (current US$) in East Asia (all income levels) and Value added (current US$) in Tajikistan?
Your answer should be very brief. 4.43e+12. In the year 1997, what is the difference between the Value added (current US$) of East Asia (all income levels) and Value added (current US$) of Togo?
Offer a very short reply. 4.43e+12. In the year 1997, what is the difference between the Value added (current US$) of Switzerland and Value added (current US$) of Tajikistan?
Keep it short and to the point. 1.95e+11. In the year 1997, what is the difference between the Value added (current US$) of Switzerland and Value added (current US$) of Togo?
Offer a terse response. 1.95e+11. In the year 1997, what is the difference between the Value added (current US$) in Tajikistan and Value added (current US$) in Togo?
Your response must be concise. -2.65e+08. In the year 1998, what is the difference between the Value added (current US$) of East Asia (all income levels) and Value added (current US$) of Switzerland?
Keep it short and to the point. 3.80e+12. In the year 1998, what is the difference between the Value added (current US$) of East Asia (all income levels) and Value added (current US$) of Tajikistan?
Keep it short and to the point. 4.01e+12. In the year 1998, what is the difference between the Value added (current US$) in East Asia (all income levels) and Value added (current US$) in Togo?
Your response must be concise. 4.01e+12. In the year 1998, what is the difference between the Value added (current US$) in Switzerland and Value added (current US$) in Tajikistan?
Offer a very short reply. 2.03e+11. In the year 1998, what is the difference between the Value added (current US$) of Switzerland and Value added (current US$) of Togo?
Your answer should be very brief. 2.03e+11. In the year 1998, what is the difference between the Value added (current US$) in Tajikistan and Value added (current US$) in Togo?
Your response must be concise. -2.06e+08. What is the ratio of the Value added (current US$) of East Asia (all income levels) in 1992 to that in 1993?
Keep it short and to the point. 0.87. What is the ratio of the Value added (current US$) in Switzerland in 1992 to that in 1993?
Offer a terse response. 1.02. What is the ratio of the Value added (current US$) in Tajikistan in 1992 to that in 1993?
Keep it short and to the point. 1.22. What is the ratio of the Value added (current US$) of Togo in 1992 to that in 1993?
Provide a short and direct response. 1.6. What is the ratio of the Value added (current US$) in East Asia (all income levels) in 1992 to that in 1994?
Make the answer very short. 0.78. What is the ratio of the Value added (current US$) of Switzerland in 1992 to that in 1994?
Your response must be concise. 0.93. What is the ratio of the Value added (current US$) in Tajikistan in 1992 to that in 1994?
Your response must be concise. 1.46. What is the ratio of the Value added (current US$) in Togo in 1992 to that in 1994?
Keep it short and to the point. 1.61. What is the ratio of the Value added (current US$) in East Asia (all income levels) in 1992 to that in 1995?
Provide a succinct answer. 0.69. What is the ratio of the Value added (current US$) in Switzerland in 1992 to that in 1995?
Provide a short and direct response. 0.79. What is the ratio of the Value added (current US$) of Tajikistan in 1992 to that in 1995?
Provide a succinct answer. 2.09. What is the ratio of the Value added (current US$) of Togo in 1992 to that in 1995?
Provide a short and direct response. 1.32. What is the ratio of the Value added (current US$) of East Asia (all income levels) in 1992 to that in 1996?
Keep it short and to the point. 0.73. What is the ratio of the Value added (current US$) in Switzerland in 1992 to that in 1996?
Keep it short and to the point. 0.81. What is the ratio of the Value added (current US$) of Tajikistan in 1992 to that in 1996?
Offer a terse response. 1.92. What is the ratio of the Value added (current US$) of Togo in 1992 to that in 1996?
Offer a terse response. 1.24. What is the ratio of the Value added (current US$) in East Asia (all income levels) in 1992 to that in 1997?
Provide a short and direct response. 0.76. What is the ratio of the Value added (current US$) of Switzerland in 1992 to that in 1997?
Provide a succinct answer. 0.92. What is the ratio of the Value added (current US$) in Tajikistan in 1992 to that in 1997?
Offer a terse response. 1.82. What is the ratio of the Value added (current US$) in Togo in 1992 to that in 1997?
Your answer should be very brief. 1.23. What is the ratio of the Value added (current US$) in East Asia (all income levels) in 1992 to that in 1998?
Your answer should be very brief. 0.84. What is the ratio of the Value added (current US$) in Switzerland in 1992 to that in 1998?
Provide a short and direct response. 0.88. What is the ratio of the Value added (current US$) of Tajikistan in 1992 to that in 1998?
Your response must be concise. 0.98. What is the ratio of the Value added (current US$) of Togo in 1992 to that in 1998?
Give a very brief answer. 0.91. What is the ratio of the Value added (current US$) in Switzerland in 1993 to that in 1994?
Your response must be concise. 0.91. What is the ratio of the Value added (current US$) of Tajikistan in 1993 to that in 1994?
Provide a succinct answer. 1.19. What is the ratio of the Value added (current US$) of Togo in 1993 to that in 1994?
Keep it short and to the point. 1.01. What is the ratio of the Value added (current US$) in East Asia (all income levels) in 1993 to that in 1995?
Make the answer very short. 0.79. What is the ratio of the Value added (current US$) of Switzerland in 1993 to that in 1995?
Offer a very short reply. 0.78. What is the ratio of the Value added (current US$) of Tajikistan in 1993 to that in 1995?
Provide a succinct answer. 1.71. What is the ratio of the Value added (current US$) in Togo in 1993 to that in 1995?
Offer a terse response. 0.83. What is the ratio of the Value added (current US$) in East Asia (all income levels) in 1993 to that in 1996?
Offer a terse response. 0.83. What is the ratio of the Value added (current US$) of Switzerland in 1993 to that in 1996?
Your response must be concise. 0.79. What is the ratio of the Value added (current US$) of Tajikistan in 1993 to that in 1996?
Offer a very short reply. 1.58. What is the ratio of the Value added (current US$) in Togo in 1993 to that in 1996?
Your answer should be compact. 0.78. What is the ratio of the Value added (current US$) of East Asia (all income levels) in 1993 to that in 1997?
Provide a short and direct response. 0.87. What is the ratio of the Value added (current US$) in Switzerland in 1993 to that in 1997?
Give a very brief answer. 0.9. What is the ratio of the Value added (current US$) in Tajikistan in 1993 to that in 1997?
Offer a very short reply. 1.5. What is the ratio of the Value added (current US$) of Togo in 1993 to that in 1997?
Provide a short and direct response. 0.77. What is the ratio of the Value added (current US$) in East Asia (all income levels) in 1993 to that in 1998?
Offer a terse response. 0.96. What is the ratio of the Value added (current US$) in Switzerland in 1993 to that in 1998?
Your answer should be compact. 0.87. What is the ratio of the Value added (current US$) of Tajikistan in 1993 to that in 1998?
Keep it short and to the point. 0.8. What is the ratio of the Value added (current US$) of Togo in 1993 to that in 1998?
Make the answer very short. 0.57. What is the ratio of the Value added (current US$) of East Asia (all income levels) in 1994 to that in 1995?
Offer a very short reply. 0.89. What is the ratio of the Value added (current US$) of Switzerland in 1994 to that in 1995?
Provide a succinct answer. 0.85. What is the ratio of the Value added (current US$) of Tajikistan in 1994 to that in 1995?
Offer a terse response. 1.44. What is the ratio of the Value added (current US$) of Togo in 1994 to that in 1995?
Offer a very short reply. 0.82. What is the ratio of the Value added (current US$) of East Asia (all income levels) in 1994 to that in 1996?
Make the answer very short. 0.94. What is the ratio of the Value added (current US$) of Switzerland in 1994 to that in 1996?
Keep it short and to the point. 0.87. What is the ratio of the Value added (current US$) of Tajikistan in 1994 to that in 1996?
Ensure brevity in your answer.  1.32. What is the ratio of the Value added (current US$) in Togo in 1994 to that in 1996?
Your response must be concise. 0.77. What is the ratio of the Value added (current US$) in Switzerland in 1994 to that in 1997?
Provide a short and direct response. 0.99. What is the ratio of the Value added (current US$) in Tajikistan in 1994 to that in 1997?
Ensure brevity in your answer.  1.25. What is the ratio of the Value added (current US$) in Togo in 1994 to that in 1997?
Your answer should be very brief. 0.76. What is the ratio of the Value added (current US$) in East Asia (all income levels) in 1994 to that in 1998?
Your answer should be compact. 1.08. What is the ratio of the Value added (current US$) in Switzerland in 1994 to that in 1998?
Your answer should be compact. 0.95. What is the ratio of the Value added (current US$) of Tajikistan in 1994 to that in 1998?
Your answer should be compact. 0.67. What is the ratio of the Value added (current US$) of Togo in 1994 to that in 1998?
Offer a very short reply. 0.56. What is the ratio of the Value added (current US$) of East Asia (all income levels) in 1995 to that in 1996?
Offer a very short reply. 1.06. What is the ratio of the Value added (current US$) of Switzerland in 1995 to that in 1996?
Offer a very short reply. 1.02. What is the ratio of the Value added (current US$) in Tajikistan in 1995 to that in 1996?
Give a very brief answer. 0.92. What is the ratio of the Value added (current US$) in Togo in 1995 to that in 1996?
Your answer should be compact. 0.94. What is the ratio of the Value added (current US$) in East Asia (all income levels) in 1995 to that in 1997?
Ensure brevity in your answer.  1.1. What is the ratio of the Value added (current US$) of Switzerland in 1995 to that in 1997?
Keep it short and to the point. 1.16. What is the ratio of the Value added (current US$) of Tajikistan in 1995 to that in 1997?
Make the answer very short. 0.87. What is the ratio of the Value added (current US$) in Togo in 1995 to that in 1997?
Your response must be concise. 0.93. What is the ratio of the Value added (current US$) in East Asia (all income levels) in 1995 to that in 1998?
Ensure brevity in your answer.  1.22. What is the ratio of the Value added (current US$) of Switzerland in 1995 to that in 1998?
Your response must be concise. 1.11. What is the ratio of the Value added (current US$) of Tajikistan in 1995 to that in 1998?
Keep it short and to the point. 0.47. What is the ratio of the Value added (current US$) in Togo in 1995 to that in 1998?
Your answer should be compact. 0.69. What is the ratio of the Value added (current US$) of East Asia (all income levels) in 1996 to that in 1997?
Your response must be concise. 1.04. What is the ratio of the Value added (current US$) of Switzerland in 1996 to that in 1997?
Your response must be concise. 1.14. What is the ratio of the Value added (current US$) in Tajikistan in 1996 to that in 1997?
Ensure brevity in your answer.  0.95. What is the ratio of the Value added (current US$) in East Asia (all income levels) in 1996 to that in 1998?
Your response must be concise. 1.15. What is the ratio of the Value added (current US$) in Switzerland in 1996 to that in 1998?
Provide a succinct answer. 1.1. What is the ratio of the Value added (current US$) of Tajikistan in 1996 to that in 1998?
Give a very brief answer. 0.51. What is the ratio of the Value added (current US$) of Togo in 1996 to that in 1998?
Offer a very short reply. 0.73. What is the ratio of the Value added (current US$) in East Asia (all income levels) in 1997 to that in 1998?
Your response must be concise. 1.11. What is the ratio of the Value added (current US$) of Switzerland in 1997 to that in 1998?
Provide a short and direct response. 0.96. What is the ratio of the Value added (current US$) of Tajikistan in 1997 to that in 1998?
Make the answer very short. 0.54. What is the ratio of the Value added (current US$) in Togo in 1997 to that in 1998?
Offer a terse response. 0.74. What is the difference between the highest and the second highest Value added (current US$) of East Asia (all income levels)?
Your response must be concise. 2.63e+11. What is the difference between the highest and the second highest Value added (current US$) of Switzerland?
Make the answer very short. 3.59e+09. What is the difference between the highest and the second highest Value added (current US$) of Tajikistan?
Provide a short and direct response. 1.32e+07. What is the difference between the highest and the second highest Value added (current US$) in Togo?
Keep it short and to the point. 7.12e+07. What is the difference between the highest and the lowest Value added (current US$) of East Asia (all income levels)?
Provide a succinct answer. 1.53e+12. What is the difference between the highest and the lowest Value added (current US$) in Switzerland?
Offer a terse response. 5.03e+1. What is the difference between the highest and the lowest Value added (current US$) in Tajikistan?
Your answer should be compact. 2.98e+08. What is the difference between the highest and the lowest Value added (current US$) of Togo?
Provide a succinct answer. 3.34e+08. 